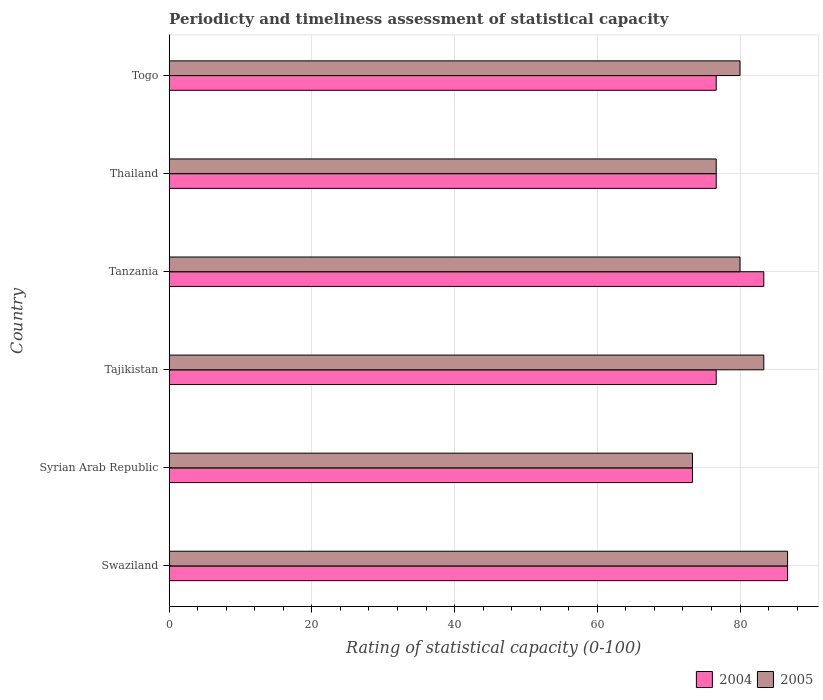How many different coloured bars are there?
Give a very brief answer. 2. How many groups of bars are there?
Your answer should be very brief. 6. Are the number of bars on each tick of the Y-axis equal?
Make the answer very short. Yes. What is the label of the 2nd group of bars from the top?
Your answer should be compact. Thailand. In how many cases, is the number of bars for a given country not equal to the number of legend labels?
Keep it short and to the point. 0. What is the rating of statistical capacity in 2005 in Togo?
Keep it short and to the point. 80. Across all countries, what is the maximum rating of statistical capacity in 2005?
Provide a short and direct response. 86.67. Across all countries, what is the minimum rating of statistical capacity in 2005?
Offer a very short reply. 73.33. In which country was the rating of statistical capacity in 2005 maximum?
Your answer should be compact. Swaziland. In which country was the rating of statistical capacity in 2004 minimum?
Provide a short and direct response. Syrian Arab Republic. What is the total rating of statistical capacity in 2004 in the graph?
Offer a terse response. 473.33. What is the difference between the rating of statistical capacity in 2005 in Tajikistan and that in Thailand?
Your response must be concise. 6.67. What is the average rating of statistical capacity in 2004 per country?
Ensure brevity in your answer.  78.89. What is the difference between the rating of statistical capacity in 2005 and rating of statistical capacity in 2004 in Thailand?
Keep it short and to the point. 0. In how many countries, is the rating of statistical capacity in 2005 greater than 80 ?
Your answer should be compact. 2. What is the ratio of the rating of statistical capacity in 2004 in Tajikistan to that in Thailand?
Your answer should be very brief. 1. Is the rating of statistical capacity in 2005 in Swaziland less than that in Tajikistan?
Your answer should be very brief. No. What is the difference between the highest and the second highest rating of statistical capacity in 2004?
Offer a very short reply. 3.33. What is the difference between the highest and the lowest rating of statistical capacity in 2004?
Provide a succinct answer. 13.33. In how many countries, is the rating of statistical capacity in 2005 greater than the average rating of statistical capacity in 2005 taken over all countries?
Keep it short and to the point. 2. Is the sum of the rating of statistical capacity in 2005 in Swaziland and Syrian Arab Republic greater than the maximum rating of statistical capacity in 2004 across all countries?
Provide a succinct answer. Yes. What does the 2nd bar from the bottom in Syrian Arab Republic represents?
Keep it short and to the point. 2005. How many bars are there?
Give a very brief answer. 12. What is the difference between two consecutive major ticks on the X-axis?
Your answer should be very brief. 20. Are the values on the major ticks of X-axis written in scientific E-notation?
Ensure brevity in your answer.  No. Does the graph contain any zero values?
Offer a very short reply. No. Does the graph contain grids?
Provide a short and direct response. Yes. Where does the legend appear in the graph?
Ensure brevity in your answer.  Bottom right. How many legend labels are there?
Keep it short and to the point. 2. What is the title of the graph?
Your answer should be very brief. Periodicty and timeliness assessment of statistical capacity. What is the label or title of the X-axis?
Make the answer very short. Rating of statistical capacity (0-100). What is the label or title of the Y-axis?
Give a very brief answer. Country. What is the Rating of statistical capacity (0-100) of 2004 in Swaziland?
Ensure brevity in your answer.  86.67. What is the Rating of statistical capacity (0-100) in 2005 in Swaziland?
Your answer should be compact. 86.67. What is the Rating of statistical capacity (0-100) in 2004 in Syrian Arab Republic?
Ensure brevity in your answer.  73.33. What is the Rating of statistical capacity (0-100) of 2005 in Syrian Arab Republic?
Provide a succinct answer. 73.33. What is the Rating of statistical capacity (0-100) in 2004 in Tajikistan?
Your answer should be very brief. 76.67. What is the Rating of statistical capacity (0-100) of 2005 in Tajikistan?
Your answer should be very brief. 83.33. What is the Rating of statistical capacity (0-100) in 2004 in Tanzania?
Your answer should be very brief. 83.33. What is the Rating of statistical capacity (0-100) of 2005 in Tanzania?
Make the answer very short. 80. What is the Rating of statistical capacity (0-100) of 2004 in Thailand?
Make the answer very short. 76.67. What is the Rating of statistical capacity (0-100) of 2005 in Thailand?
Ensure brevity in your answer.  76.67. What is the Rating of statistical capacity (0-100) of 2004 in Togo?
Give a very brief answer. 76.67. What is the Rating of statistical capacity (0-100) of 2005 in Togo?
Offer a very short reply. 80. Across all countries, what is the maximum Rating of statistical capacity (0-100) in 2004?
Make the answer very short. 86.67. Across all countries, what is the maximum Rating of statistical capacity (0-100) of 2005?
Offer a terse response. 86.67. Across all countries, what is the minimum Rating of statistical capacity (0-100) in 2004?
Offer a terse response. 73.33. Across all countries, what is the minimum Rating of statistical capacity (0-100) in 2005?
Ensure brevity in your answer.  73.33. What is the total Rating of statistical capacity (0-100) of 2004 in the graph?
Give a very brief answer. 473.33. What is the total Rating of statistical capacity (0-100) of 2005 in the graph?
Offer a very short reply. 480. What is the difference between the Rating of statistical capacity (0-100) of 2004 in Swaziland and that in Syrian Arab Republic?
Provide a succinct answer. 13.33. What is the difference between the Rating of statistical capacity (0-100) in 2005 in Swaziland and that in Syrian Arab Republic?
Keep it short and to the point. 13.33. What is the difference between the Rating of statistical capacity (0-100) in 2004 in Swaziland and that in Tajikistan?
Your answer should be very brief. 10. What is the difference between the Rating of statistical capacity (0-100) in 2004 in Swaziland and that in Tanzania?
Your answer should be very brief. 3.33. What is the difference between the Rating of statistical capacity (0-100) in 2005 in Swaziland and that in Tanzania?
Ensure brevity in your answer.  6.67. What is the difference between the Rating of statistical capacity (0-100) of 2005 in Swaziland and that in Thailand?
Provide a succinct answer. 10. What is the difference between the Rating of statistical capacity (0-100) of 2004 in Swaziland and that in Togo?
Give a very brief answer. 10. What is the difference between the Rating of statistical capacity (0-100) of 2005 in Syrian Arab Republic and that in Tajikistan?
Provide a succinct answer. -10. What is the difference between the Rating of statistical capacity (0-100) in 2004 in Syrian Arab Republic and that in Tanzania?
Your response must be concise. -10. What is the difference between the Rating of statistical capacity (0-100) of 2005 in Syrian Arab Republic and that in Tanzania?
Your response must be concise. -6.67. What is the difference between the Rating of statistical capacity (0-100) in 2005 in Syrian Arab Republic and that in Thailand?
Keep it short and to the point. -3.33. What is the difference between the Rating of statistical capacity (0-100) of 2004 in Syrian Arab Republic and that in Togo?
Your response must be concise. -3.33. What is the difference between the Rating of statistical capacity (0-100) of 2005 in Syrian Arab Republic and that in Togo?
Give a very brief answer. -6.67. What is the difference between the Rating of statistical capacity (0-100) of 2004 in Tajikistan and that in Tanzania?
Keep it short and to the point. -6.67. What is the difference between the Rating of statistical capacity (0-100) in 2005 in Tajikistan and that in Tanzania?
Provide a succinct answer. 3.33. What is the difference between the Rating of statistical capacity (0-100) of 2004 in Tajikistan and that in Thailand?
Your answer should be compact. 0. What is the difference between the Rating of statistical capacity (0-100) of 2005 in Tajikistan and that in Thailand?
Give a very brief answer. 6.67. What is the difference between the Rating of statistical capacity (0-100) of 2004 in Tajikistan and that in Togo?
Offer a very short reply. 0. What is the difference between the Rating of statistical capacity (0-100) in 2005 in Tajikistan and that in Togo?
Provide a succinct answer. 3.33. What is the difference between the Rating of statistical capacity (0-100) of 2004 in Tanzania and that in Thailand?
Give a very brief answer. 6.67. What is the difference between the Rating of statistical capacity (0-100) in 2005 in Tanzania and that in Togo?
Provide a succinct answer. 0. What is the difference between the Rating of statistical capacity (0-100) in 2005 in Thailand and that in Togo?
Make the answer very short. -3.33. What is the difference between the Rating of statistical capacity (0-100) of 2004 in Swaziland and the Rating of statistical capacity (0-100) of 2005 in Syrian Arab Republic?
Keep it short and to the point. 13.33. What is the difference between the Rating of statistical capacity (0-100) of 2004 in Swaziland and the Rating of statistical capacity (0-100) of 2005 in Togo?
Your answer should be compact. 6.67. What is the difference between the Rating of statistical capacity (0-100) of 2004 in Syrian Arab Republic and the Rating of statistical capacity (0-100) of 2005 in Tajikistan?
Your answer should be compact. -10. What is the difference between the Rating of statistical capacity (0-100) in 2004 in Syrian Arab Republic and the Rating of statistical capacity (0-100) in 2005 in Tanzania?
Your answer should be compact. -6.67. What is the difference between the Rating of statistical capacity (0-100) in 2004 in Syrian Arab Republic and the Rating of statistical capacity (0-100) in 2005 in Thailand?
Your response must be concise. -3.33. What is the difference between the Rating of statistical capacity (0-100) of 2004 in Syrian Arab Republic and the Rating of statistical capacity (0-100) of 2005 in Togo?
Your answer should be very brief. -6.67. What is the difference between the Rating of statistical capacity (0-100) of 2004 in Tajikistan and the Rating of statistical capacity (0-100) of 2005 in Togo?
Your response must be concise. -3.33. What is the difference between the Rating of statistical capacity (0-100) of 2004 in Tanzania and the Rating of statistical capacity (0-100) of 2005 in Togo?
Offer a very short reply. 3.33. What is the average Rating of statistical capacity (0-100) in 2004 per country?
Provide a short and direct response. 78.89. What is the difference between the Rating of statistical capacity (0-100) of 2004 and Rating of statistical capacity (0-100) of 2005 in Swaziland?
Your answer should be very brief. 0. What is the difference between the Rating of statistical capacity (0-100) in 2004 and Rating of statistical capacity (0-100) in 2005 in Tajikistan?
Provide a succinct answer. -6.67. What is the ratio of the Rating of statistical capacity (0-100) in 2004 in Swaziland to that in Syrian Arab Republic?
Give a very brief answer. 1.18. What is the ratio of the Rating of statistical capacity (0-100) of 2005 in Swaziland to that in Syrian Arab Republic?
Offer a terse response. 1.18. What is the ratio of the Rating of statistical capacity (0-100) of 2004 in Swaziland to that in Tajikistan?
Keep it short and to the point. 1.13. What is the ratio of the Rating of statistical capacity (0-100) of 2004 in Swaziland to that in Thailand?
Provide a succinct answer. 1.13. What is the ratio of the Rating of statistical capacity (0-100) of 2005 in Swaziland to that in Thailand?
Ensure brevity in your answer.  1.13. What is the ratio of the Rating of statistical capacity (0-100) of 2004 in Swaziland to that in Togo?
Your answer should be compact. 1.13. What is the ratio of the Rating of statistical capacity (0-100) of 2005 in Swaziland to that in Togo?
Give a very brief answer. 1.08. What is the ratio of the Rating of statistical capacity (0-100) in 2004 in Syrian Arab Republic to that in Tajikistan?
Ensure brevity in your answer.  0.96. What is the ratio of the Rating of statistical capacity (0-100) of 2005 in Syrian Arab Republic to that in Tajikistan?
Keep it short and to the point. 0.88. What is the ratio of the Rating of statistical capacity (0-100) in 2004 in Syrian Arab Republic to that in Thailand?
Ensure brevity in your answer.  0.96. What is the ratio of the Rating of statistical capacity (0-100) in 2005 in Syrian Arab Republic to that in Thailand?
Keep it short and to the point. 0.96. What is the ratio of the Rating of statistical capacity (0-100) of 2004 in Syrian Arab Republic to that in Togo?
Make the answer very short. 0.96. What is the ratio of the Rating of statistical capacity (0-100) of 2005 in Syrian Arab Republic to that in Togo?
Provide a succinct answer. 0.92. What is the ratio of the Rating of statistical capacity (0-100) in 2004 in Tajikistan to that in Tanzania?
Ensure brevity in your answer.  0.92. What is the ratio of the Rating of statistical capacity (0-100) of 2005 in Tajikistan to that in Tanzania?
Your response must be concise. 1.04. What is the ratio of the Rating of statistical capacity (0-100) in 2004 in Tajikistan to that in Thailand?
Offer a very short reply. 1. What is the ratio of the Rating of statistical capacity (0-100) in 2005 in Tajikistan to that in Thailand?
Your answer should be compact. 1.09. What is the ratio of the Rating of statistical capacity (0-100) in 2005 in Tajikistan to that in Togo?
Provide a short and direct response. 1.04. What is the ratio of the Rating of statistical capacity (0-100) of 2004 in Tanzania to that in Thailand?
Make the answer very short. 1.09. What is the ratio of the Rating of statistical capacity (0-100) of 2005 in Tanzania to that in Thailand?
Provide a succinct answer. 1.04. What is the ratio of the Rating of statistical capacity (0-100) in 2004 in Tanzania to that in Togo?
Make the answer very short. 1.09. What is the ratio of the Rating of statistical capacity (0-100) in 2005 in Tanzania to that in Togo?
Your answer should be very brief. 1. What is the difference between the highest and the lowest Rating of statistical capacity (0-100) in 2004?
Your answer should be very brief. 13.33. What is the difference between the highest and the lowest Rating of statistical capacity (0-100) in 2005?
Provide a short and direct response. 13.33. 